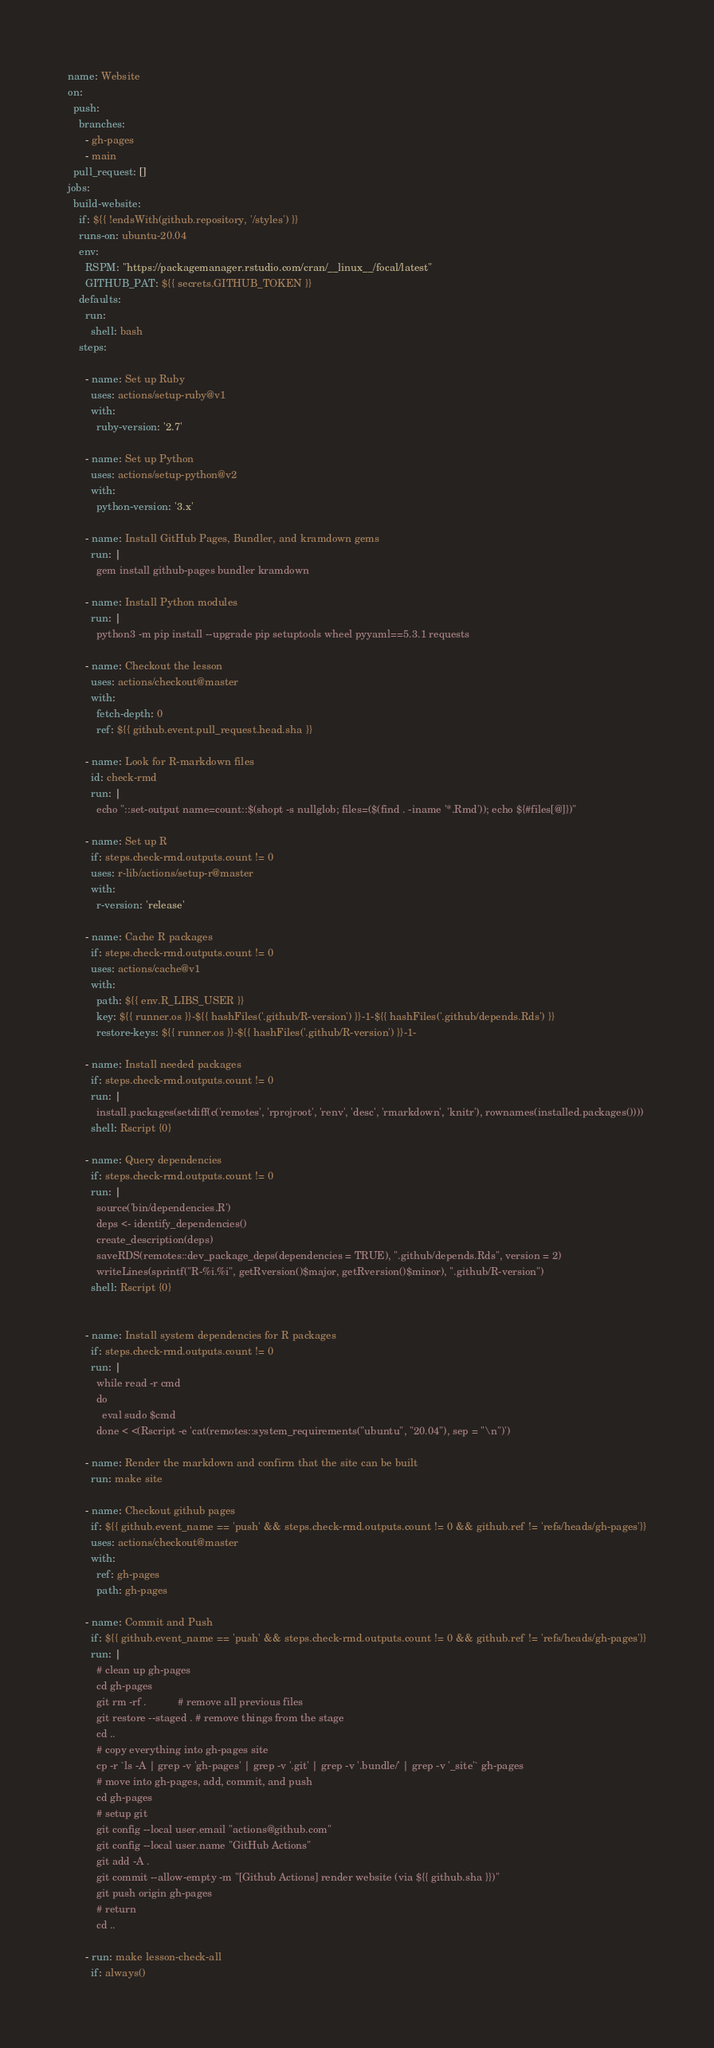<code> <loc_0><loc_0><loc_500><loc_500><_YAML_>name: Website
on:
  push:
    branches:
      - gh-pages
      - main
  pull_request: []
jobs:
  build-website:
    if: ${{ !endsWith(github.repository, '/styles') }}
    runs-on: ubuntu-20.04
    env:
      RSPM: "https://packagemanager.rstudio.com/cran/__linux__/focal/latest"
      GITHUB_PAT: ${{ secrets.GITHUB_TOKEN }}
    defaults:
      run:
        shell: bash
    steps:

      - name: Set up Ruby
        uses: actions/setup-ruby@v1
        with:
          ruby-version: '2.7'

      - name: Set up Python
        uses: actions/setup-python@v2
        with:
          python-version: '3.x'

      - name: Install GitHub Pages, Bundler, and kramdown gems
        run: |
          gem install github-pages bundler kramdown

      - name: Install Python modules
        run: |
          python3 -m pip install --upgrade pip setuptools wheel pyyaml==5.3.1 requests

      - name: Checkout the lesson
        uses: actions/checkout@master
        with:
          fetch-depth: 0
          ref: ${{ github.event.pull_request.head.sha }}

      - name: Look for R-markdown files
        id: check-rmd
        run: |
          echo "::set-output name=count::$(shopt -s nullglob; files=($(find . -iname '*.Rmd')); echo ${#files[@]})"

      - name: Set up R
        if: steps.check-rmd.outputs.count != 0
        uses: r-lib/actions/setup-r@master
        with:
          r-version: 'release'

      - name: Cache R packages
        if: steps.check-rmd.outputs.count != 0
        uses: actions/cache@v1
        with:
          path: ${{ env.R_LIBS_USER }}
          key: ${{ runner.os }}-${{ hashFiles('.github/R-version') }}-1-${{ hashFiles('.github/depends.Rds') }}
          restore-keys: ${{ runner.os }}-${{ hashFiles('.github/R-version') }}-1-

      - name: Install needed packages
        if: steps.check-rmd.outputs.count != 0
        run: |
          install.packages(setdiff(c('remotes', 'rprojroot', 'renv', 'desc', 'rmarkdown', 'knitr'), rownames(installed.packages())))
        shell: Rscript {0}

      - name: Query dependencies
        if: steps.check-rmd.outputs.count != 0
        run: |
          source('bin/dependencies.R')
          deps <- identify_dependencies()
          create_description(deps)
          saveRDS(remotes::dev_package_deps(dependencies = TRUE), ".github/depends.Rds", version = 2)
          writeLines(sprintf("R-%i.%i", getRversion()$major, getRversion()$minor), ".github/R-version")
        shell: Rscript {0}


      - name: Install system dependencies for R packages
        if: steps.check-rmd.outputs.count != 0
        run: |
          while read -r cmd
          do
            eval sudo $cmd
          done < <(Rscript -e 'cat(remotes::system_requirements("ubuntu", "20.04"), sep = "\n")')

      - name: Render the markdown and confirm that the site can be built
        run: make site

      - name: Checkout github pages
        if: ${{ github.event_name == 'push' && steps.check-rmd.outputs.count != 0 && github.ref != 'refs/heads/gh-pages'}}
        uses: actions/checkout@master
        with:
          ref: gh-pages
          path: gh-pages

      - name: Commit and Push
        if: ${{ github.event_name == 'push' && steps.check-rmd.outputs.count != 0 && github.ref != 'refs/heads/gh-pages'}}
        run: |
          # clean up gh-pages
          cd gh-pages
          git rm -rf .           # remove all previous files
          git restore --staged . # remove things from the stage
          cd ..
          # copy everything into gh-pages site
          cp -r `ls -A | grep -v 'gh-pages' | grep -v '.git' | grep -v '.bundle/' | grep -v '_site'` gh-pages
          # move into gh-pages, add, commit, and push
          cd gh-pages
          # setup git
          git config --local user.email "actions@github.com"
          git config --local user.name "GitHub Actions"
          git add -A .
          git commit --allow-empty -m "[Github Actions] render website (via ${{ github.sha }})"
          git push origin gh-pages
          # return
          cd ..

      - run: make lesson-check-all
        if: always()
</code> 